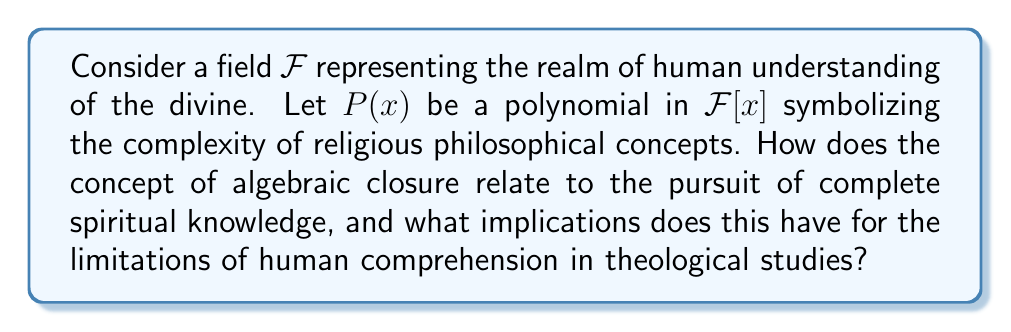Can you answer this question? 1. In field theory, an algebraic closure of a field $F$ is an algebraic extension $\overline{F}$ of $F$ that is algebraically closed. This means that every non-constant polynomial in $\overline{F}[x]$ has a root in $\overline{F}$.

2. In our analogy, let $F$ represent human understanding of the divine, and $P(x)$ represent complex religious philosophical concepts.

3. The process of finding an algebraic closure $\overline{F}$ can be seen as the pursuit of complete spiritual knowledge or ultimate truth.

4. Properties of algebraic closure relevant to this analogy:

   a) Existence: Every field has an algebraic closure. This suggests that for any level of understanding, there exists a more complete comprehension.

   b) Uniqueness up to isomorphism: While the algebraic closure is unique, the isomorphism allows for different representations. This could represent various religious traditions approaching the same ultimate truth.

   c) Transcendence degree: $\overline{F}$ has the same transcendence degree as $F$ over the prime field. This implies that some aspects of the divine may remain transcendent even in the most complete understanding.

5. Implications for theological studies:

   a) The pursuit of knowledge is infinite: Just as $\overline{F}$ contains roots for all polynomials, the quest for spiritual understanding is ongoing.

   b) Human limitations: The construction of $\overline{F}$ often requires infinite steps, suggesting that complete understanding may be beyond finite human capacity.

   c) Unity in diversity: Different approaches (isomorphisms) can lead to equivalent understandings of the divine.

   d) Mystery remains: The preservation of transcendence degree implies that even in the most complete understanding, some aspects of the divine may remain mysterious.
Answer: Algebraic closure represents the ideal of complete spiritual knowledge, implying an infinite pursuit of understanding with persistent divine mystery. 